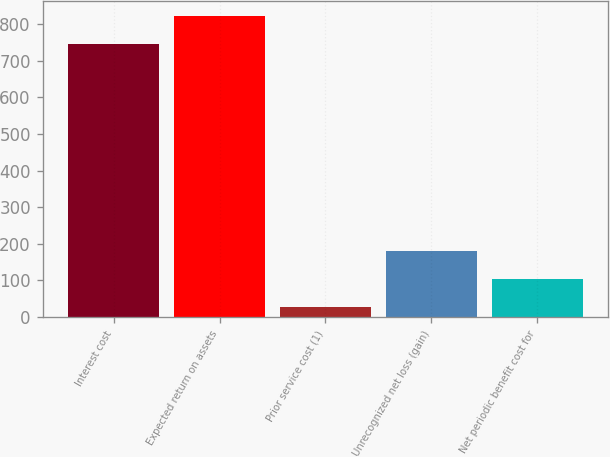Convert chart. <chart><loc_0><loc_0><loc_500><loc_500><bar_chart><fcel>Interest cost<fcel>Expected return on assets<fcel>Prior service cost (1)<fcel>Unrecognized net loss (gain)<fcel>Net periodic benefit cost for<nl><fcel>746<fcel>821.8<fcel>28<fcel>179.6<fcel>103.8<nl></chart> 